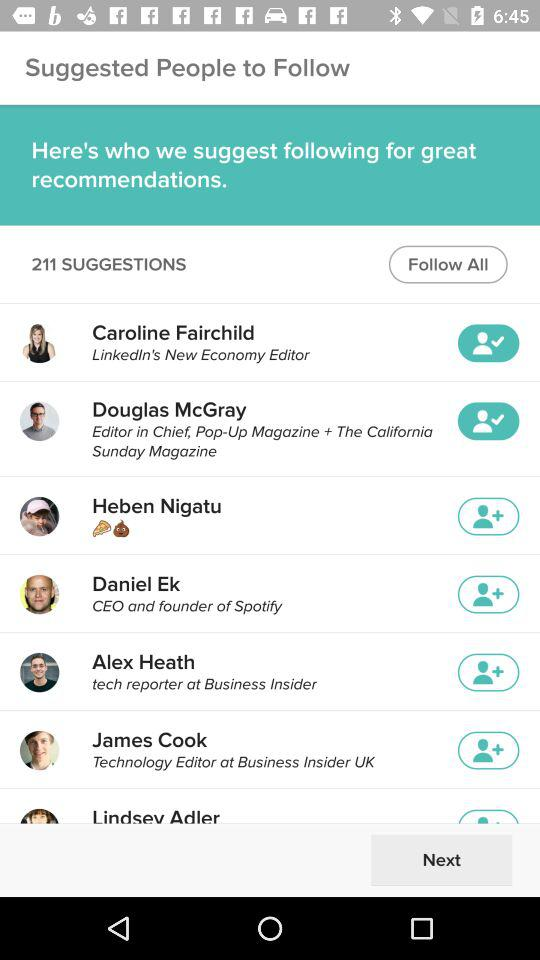How many suggestions are there? There are 211 suggestions. 